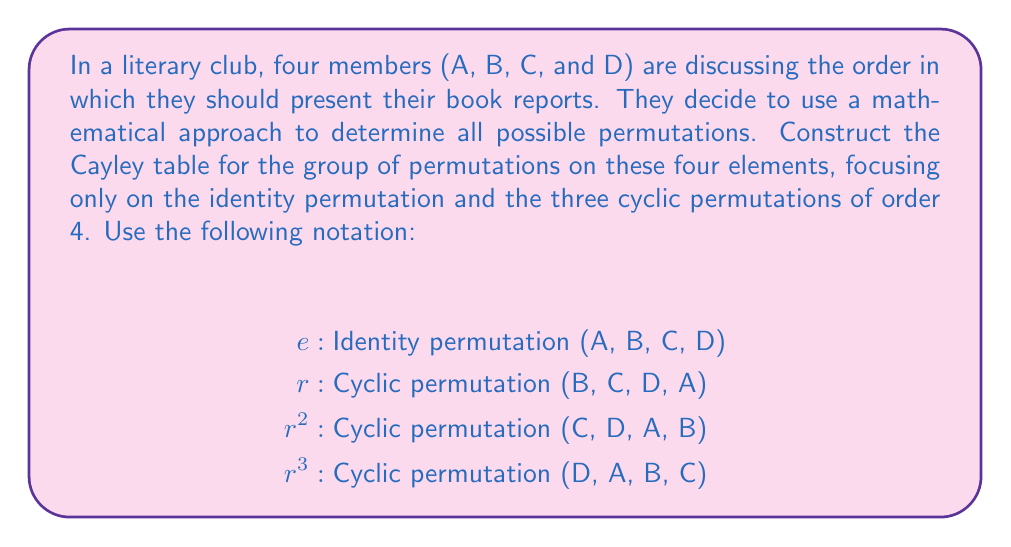What is the answer to this math problem? To construct the Cayley table for this group, we need to understand how the permutations compose with each other. Let's go through the process step-by-step:

1) First, we identify the elements of our group: $\{e, r, r^2, r^3\}$

2) We create a 4x4 table with these elements as row and column headers.

3) For each cell in the table, we compose the row element with the column element.

4) To compose permutations, we apply the rightmost permutation first, then the left one.

Let's work through a few examples:

a) $e \circ e = e$ (identity composed with identity is identity)
b) $r \circ e = r$ (any element composed with identity is itself)
c) $r \circ r = r^2$ (rotating once, then rotating again is the same as rotating twice)
d) $r \circ r^2 = r^3$ (rotating once, then rotating twice is the same as rotating thrice)
e) $r \circ r^3 = e$ (rotating once, then thrice brings us back to the start)

Continuing this process for all combinations, we get the following Cayley table:

$$
\begin{array}{c|cccc}
\circ & e & r & r^2 & r^3 \\
\hline
e & e & r & r^2 & r^3 \\
r & r & r^2 & r^3 & e \\
r^2 & r^2 & r^3 & e & r \\
r^3 & r^3 & e & r & r^2
\end{array}
$$

This table represents the group $C_4$, the cyclic group of order 4.
Answer: The Cayley table for the group of permutations on four elements, focusing on the identity and cyclic permutations of order 4, is:

$$
\begin{array}{c|cccc}
\circ & e & r & r^2 & r^3 \\
\hline
e & e & r & r^2 & r^3 \\
r & r & r^2 & r^3 & e \\
r^2 & r^2 & r^3 & e & r \\
r^3 & r^3 & e & r & r^2
\end{array}
$$ 